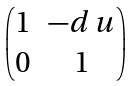<formula> <loc_0><loc_0><loc_500><loc_500>\begin{pmatrix} 1 & - d \, u \\ 0 & 1 \end{pmatrix}</formula> 